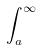Convert formula to latex. <formula><loc_0><loc_0><loc_500><loc_500>\int _ { a } ^ { \infty }</formula> 